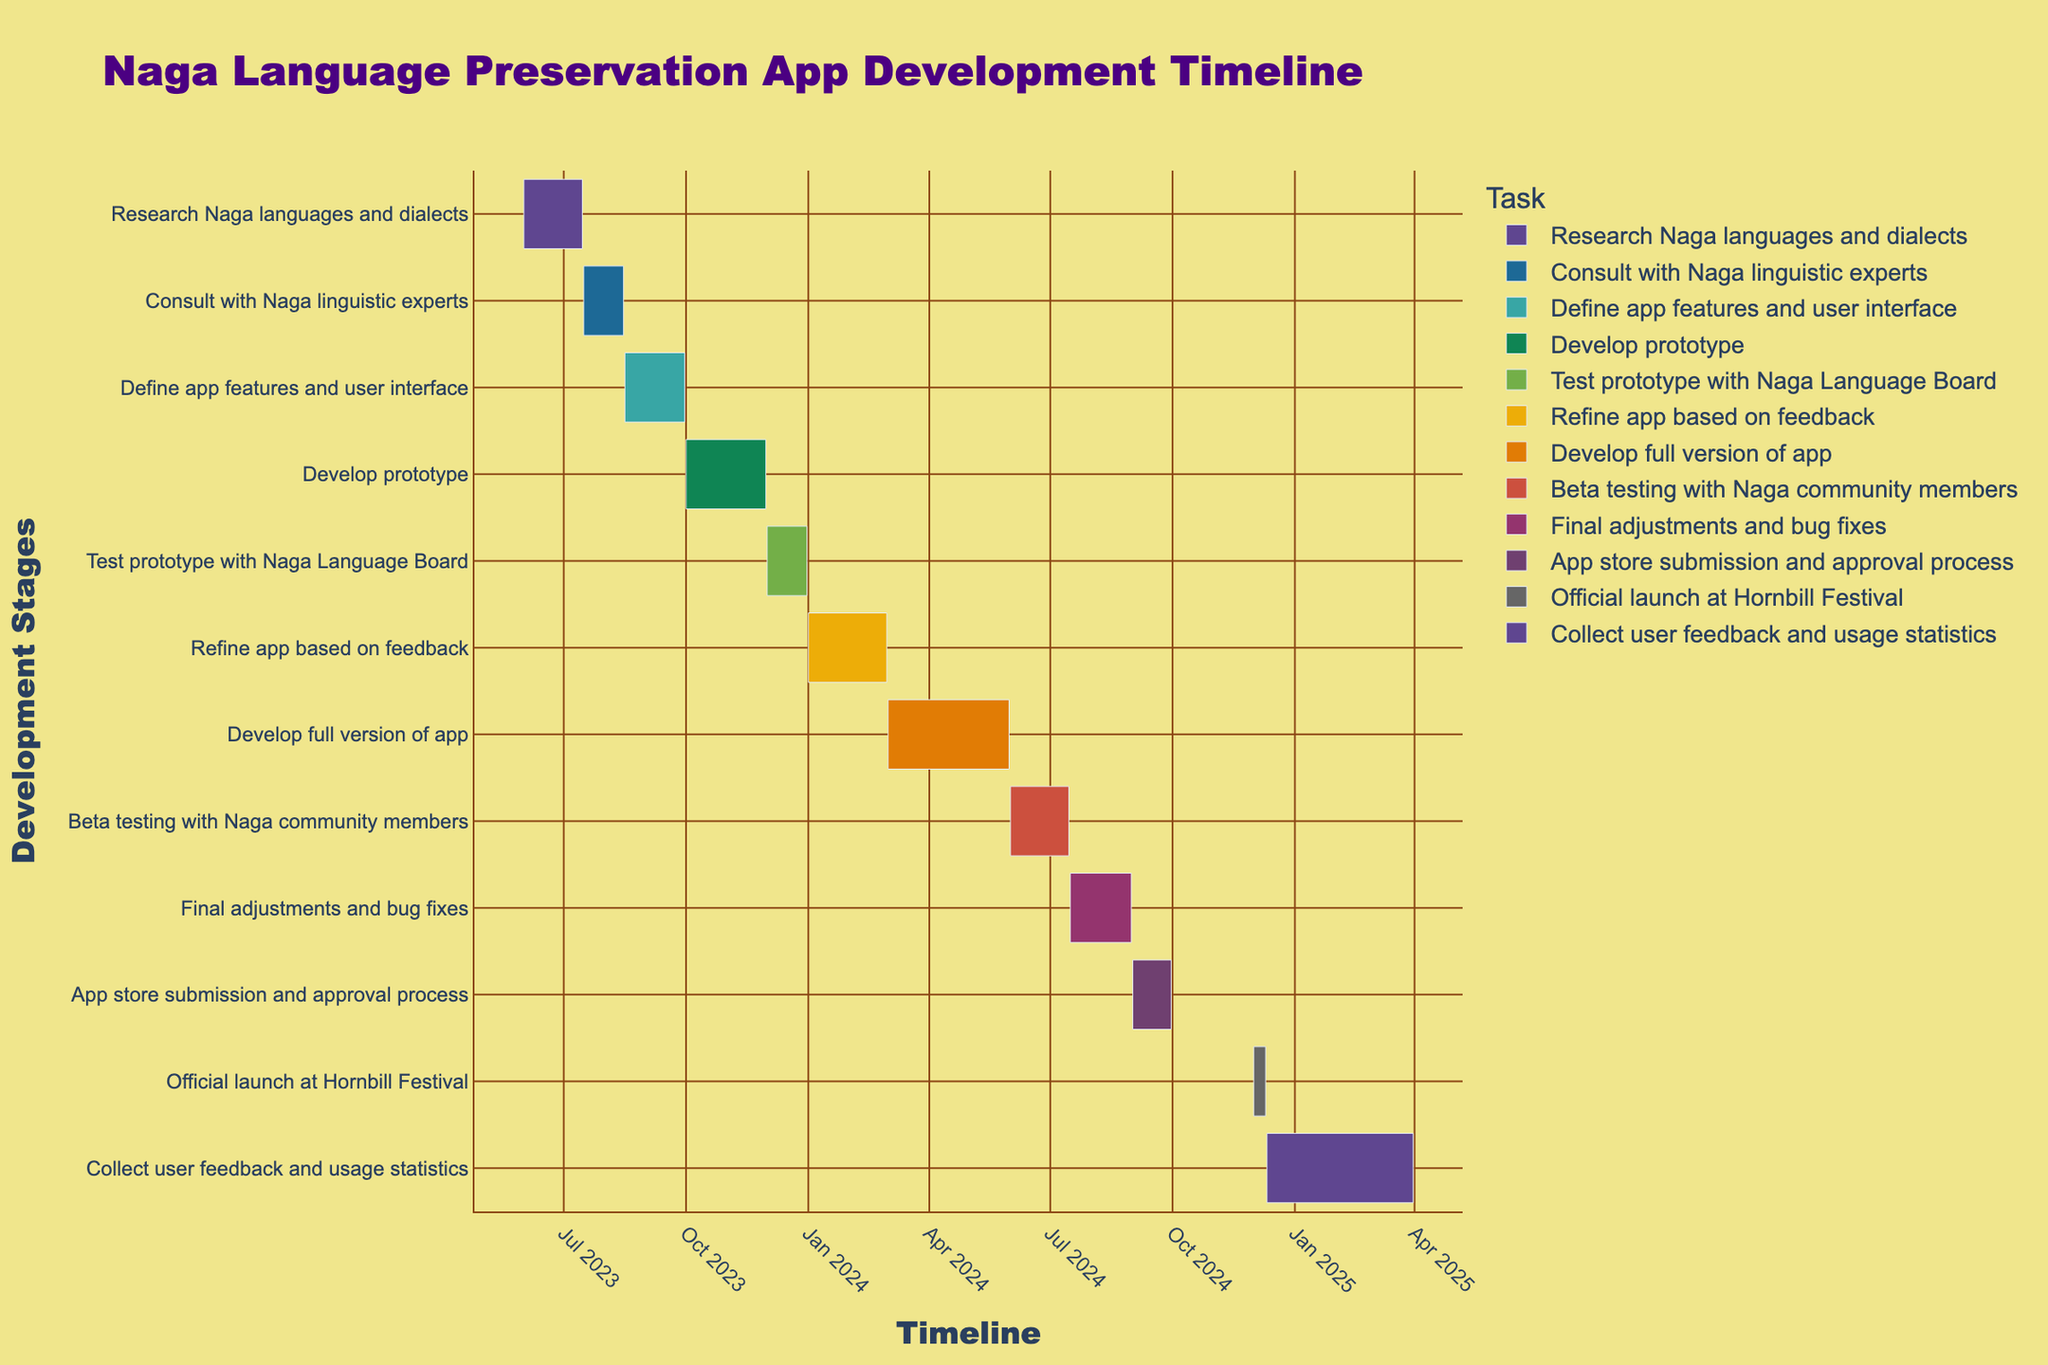What's the title of the figure? The title is prominently displayed at the top of the figure. It is designed to capture the viewer's attention and provide context about the overall content of the plot.
Answer: Naga Language Preservation App Development Timeline When does the "Develop prototype" stage start and end? The "Develop prototype" stage is marked by a bar on the timeline. Examine the start and end points on the x-axis for this specific bar to determine the dates.
Answer: 2023-10-01 to 2023-11-30 How long is the "Define app features and user interface" stage? To find the duration, look at the start and end dates for the "Define app features and user interface" stage on the figure, then calculate the difference.
Answer: 1.5 months Which stage immediately follows the "Beta testing with Naga community members" stage? By following the sequential order of tasks on the timeline, you can identify the next stage that comes right after "Beta testing with Naga community members."
Answer: Final adjustments and bug fixes How many stages are there from the conceptualization to the official app launch? Count each stage's bar starting from the earliest stage in the timeline up to the official launch event.
Answer: 10 stages Which stage has the shortest duration? Compare the length of all the bars representing each stage on the Gantt chart. The shortest bar indicates the stage with the shortest duration.
Answer: Official launch at Hornbill Festival How long will it take from "Develop full version of app" to the "Official launch"? Identify the start date of "Develop full version of app" and the end date of the "Official launch." Calculate the total duration in months by determining the difference in time between these two dates.
Answer: 9 months Which stages occur entirely within the year 2024? Identify the stages that start and end between January 1, 2024, and December 31, 2024. Ensure that both the start and end dates fall within this range.
Answer: Refine app based on feedback, Develop full version of app, Beta testing with Naga community members, Final adjustments and bug fixes, App store submission and approval process When does the "Consult with Naga linguistic experts" stage end? Locate the specific bar for "Consult with Naga linguistic experts" on the timeline and note its end point on the x-axis to determine the date.
Answer: 2023-08-15 What's the total duration for the entire project from the start of "Research Naga languages and dialects" to the end of "Collect user feedback and usage statistics"? Determine the start date of the earliest stage and the end date of the latest stage. Calculate the total time span this includes.
Answer: Approximately 22 months 